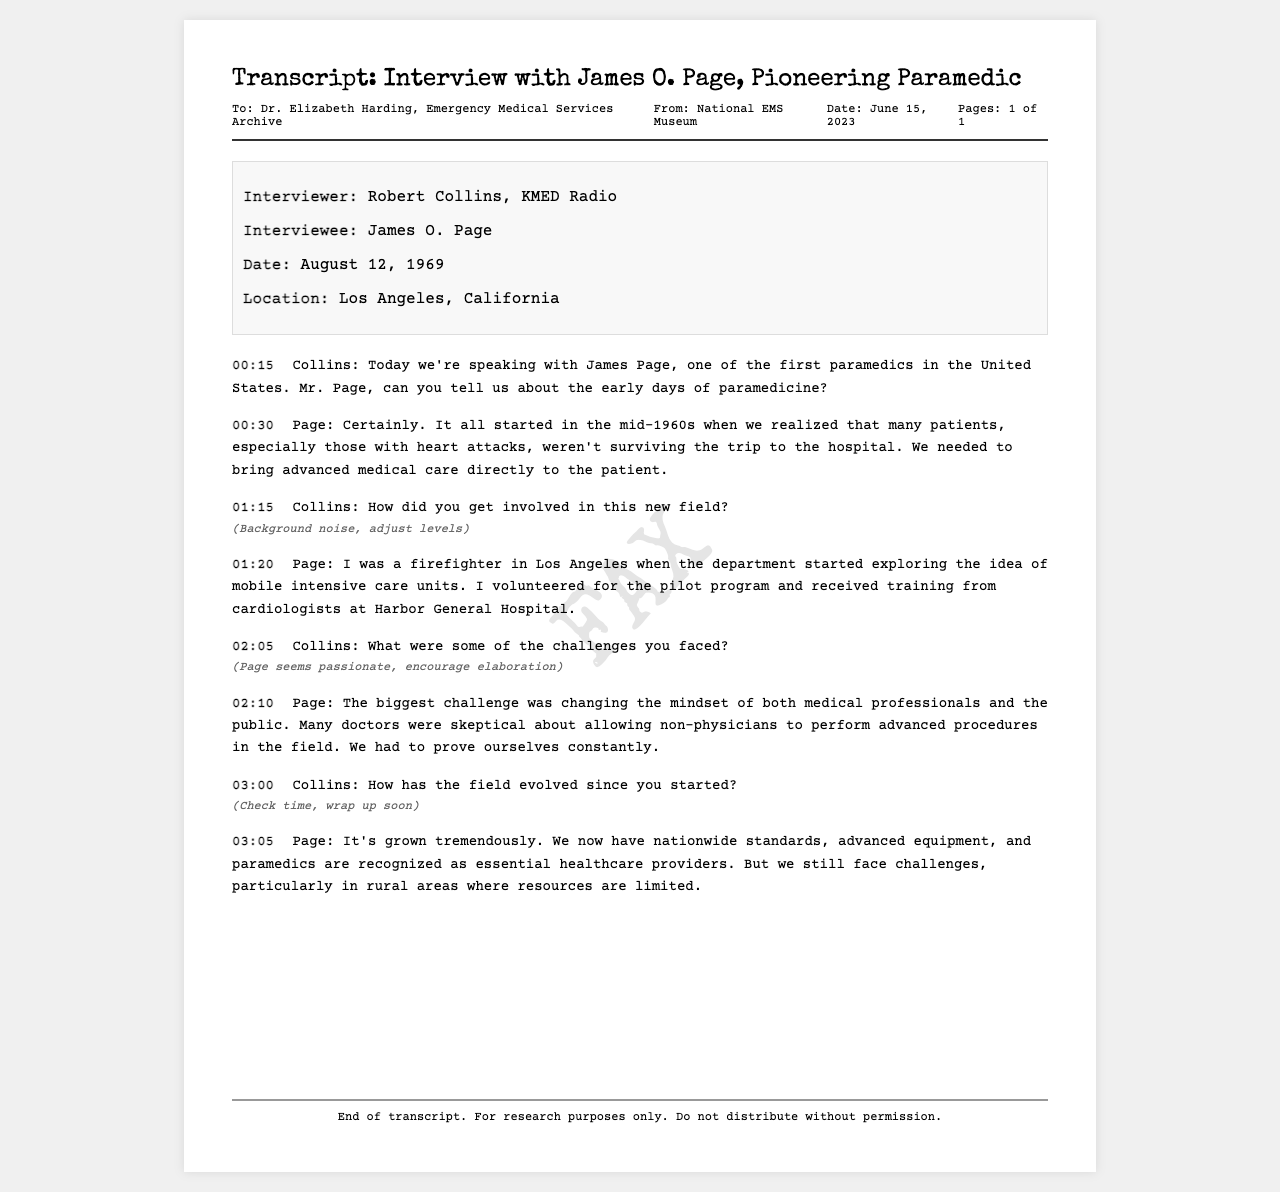What is the name of the interviewer? The name of the interviewer is listed in the interview details section of the document.
Answer: Robert Collins What is the date of the interview? The date is specified in the interview details section, providing crucial context for the interview.
Answer: August 12, 1969 Who is the interviewee in this document? The interviewee is mentioned directly in the interview details, indicating who was being interviewed.
Answer: James O. Page What city was the interview conducted in? The location of the interview is noted in the interview details section, important for historical context.
Answer: Los Angeles, California What was one major challenge faced by James O. Page? The challenge is indicated within Page's responses regarding public and professional skepticism, important for understanding paramedicine's history.
Answer: Changing the mindset At what time did Collins ask about the evolution of the field? The time references provide specific moments in the conversation and are crucial for understanding interview flow.
Answer: 03:00 What did Page call the early medical response units? It is mentioned in the interview, reflecting the terminology and developments in emergency services during that time.
Answer: Mobile intensive care units What does the footer say about the use of the transcript? The footer provides guidelines on how the document should be used, revealing its purpose.
Answer: For research purposes only. Do not distribute without permission 